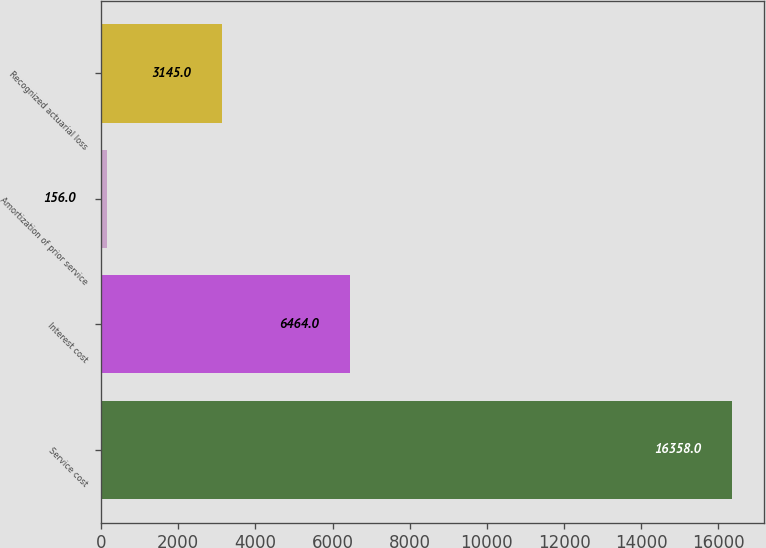Convert chart to OTSL. <chart><loc_0><loc_0><loc_500><loc_500><bar_chart><fcel>Service cost<fcel>Interest cost<fcel>Amortization of prior service<fcel>Recognized actuarial loss<nl><fcel>16358<fcel>6464<fcel>156<fcel>3145<nl></chart> 